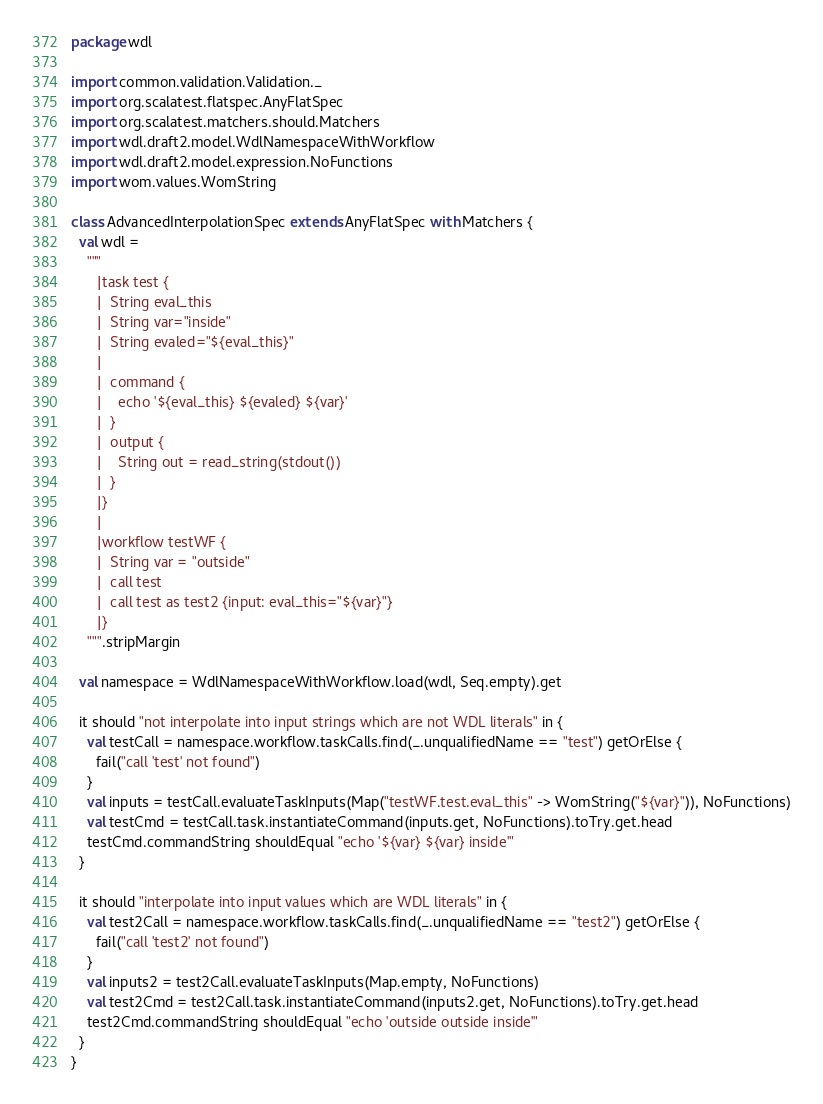Convert code to text. <code><loc_0><loc_0><loc_500><loc_500><_Scala_>package wdl

import common.validation.Validation._
import org.scalatest.flatspec.AnyFlatSpec
import org.scalatest.matchers.should.Matchers
import wdl.draft2.model.WdlNamespaceWithWorkflow
import wdl.draft2.model.expression.NoFunctions
import wom.values.WomString

class AdvancedInterpolationSpec extends AnyFlatSpec with Matchers {
  val wdl =
    """
      |task test {
      |  String eval_this
      |  String var="inside"
      |  String evaled="${eval_this}"
      |
      |  command {
      |    echo '${eval_this} ${evaled} ${var}'
      |  }
      |  output {
      |    String out = read_string(stdout())
      |  }
      |}
      |
      |workflow testWF {
      |  String var = "outside"
      |  call test
      |  call test as test2 {input: eval_this="${var}"}
      |}
    """.stripMargin

  val namespace = WdlNamespaceWithWorkflow.load(wdl, Seq.empty).get

  it should "not interpolate into input strings which are not WDL literals" in {
    val testCall = namespace.workflow.taskCalls.find(_.unqualifiedName == "test") getOrElse {
      fail("call 'test' not found")
    }
    val inputs = testCall.evaluateTaskInputs(Map("testWF.test.eval_this" -> WomString("${var}")), NoFunctions)
    val testCmd = testCall.task.instantiateCommand(inputs.get, NoFunctions).toTry.get.head
    testCmd.commandString shouldEqual "echo '${var} ${var} inside'"
  }

  it should "interpolate into input values which are WDL literals" in {
    val test2Call = namespace.workflow.taskCalls.find(_.unqualifiedName == "test2") getOrElse {
      fail("call 'test2' not found")
    }
    val inputs2 = test2Call.evaluateTaskInputs(Map.empty, NoFunctions)
    val test2Cmd = test2Call.task.instantiateCommand(inputs2.get, NoFunctions).toTry.get.head
    test2Cmd.commandString shouldEqual "echo 'outside outside inside'"
  }
}
</code> 